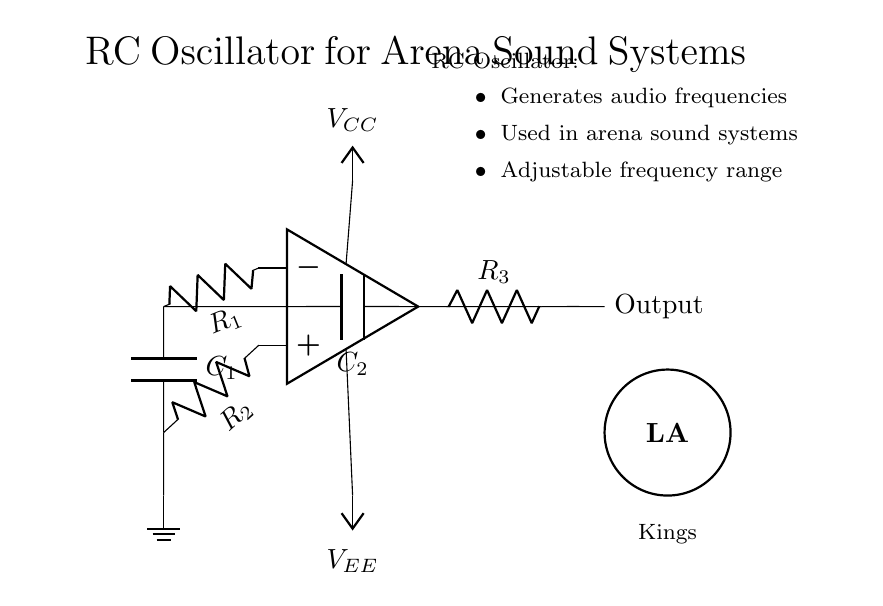What is the type of circuit shown? The circuit is an RC oscillator, which is characterized by its use of resistors and capacitors to generate oscillations. The label at the top clearly indicates this function.
Answer: RC oscillator What components are used in the feedback loop? The feedback loop consists of resistors R2 and R3, and capacitor C2. These components are connected to the op-amp's output and the inverting input, which is typical in oscillator designs for controlling the frequency of oscillation.
Answer: R2, R3, C2 What is the purpose of the operational amplifier in this circuit? The operational amplifier amplifies the signal to generate oscillations. It serves as the heart of the oscillator, where positive feedback is applied to create stable oscillatory behavior.
Answer: Signal amplification What does the label VCC signify? VCC represents the positive power supply voltage required for the operation of the op-amp. This is a common label in circuit diagrams to denote the positive voltage supply line.
Answer: Positive power supply What frequency range is the RC oscillator capable of generating? The oscillator is adjustable and can generate audio frequencies, which typically range from 20 Hz to 20 kHz. This is suitable for applications in arena sound systems where such frequencies are crucial.
Answer: Audio frequencies How does the capacitor C1 contribute to the oscillator's function? Capacitor C1, located in the feedback loop, plays a critical role in determining the frequency of oscillation. It, along with the resistors, sets the timing characteristics that dictate how fast the circuit oscillates.
Answer: Frequency determination What is the output of the circuit used for? The output is used for delivering the generated audio frequencies to the sound system, effectively allowing controlled sound generation suitable for different events in arenas.
Answer: Audio output 